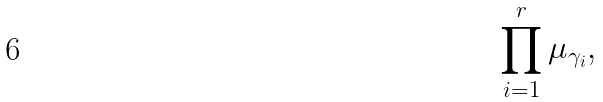<formula> <loc_0><loc_0><loc_500><loc_500>\prod _ { i = 1 } ^ { r } \mu _ { \gamma _ { i } } ,</formula> 